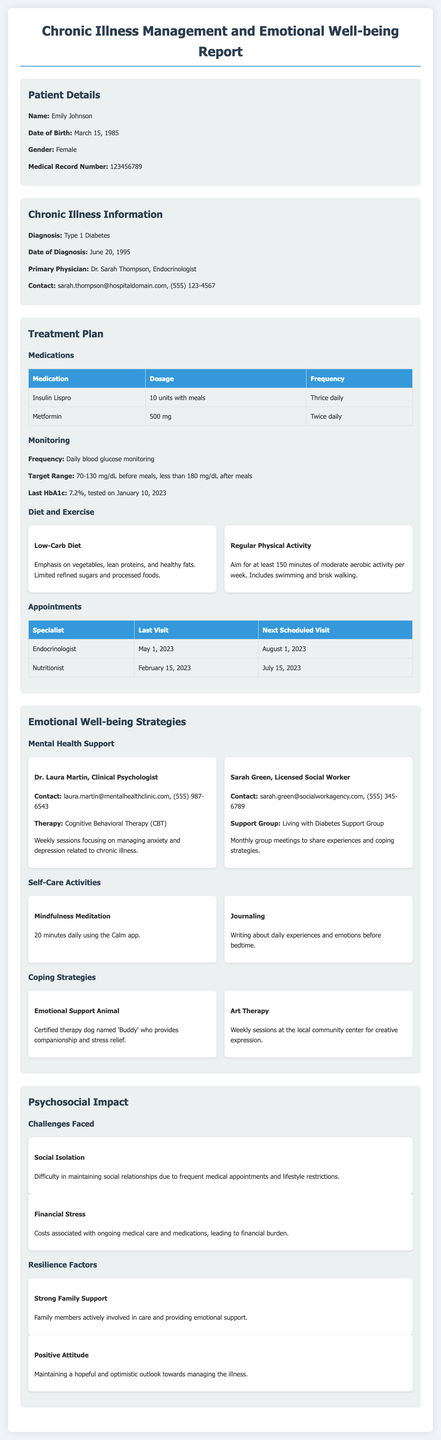what is the patient's name? The patient's name is mentioned in the document under Patient Details.
Answer: Emily Johnson what is the diagnosis? The diagnosis is stated in the Chronic Illness Information section of the report.
Answer: Type 1 Diabetes what medication is prescribed for the patient? The report specifies the medications in the Treatment Plan section.
Answer: Insulin Lispro when was the last visit to the endocrinologist? The date of the last visit is listed in the Appointments subsection of the Treatment Plan.
Answer: May 1, 2023 who provides mental health support? The Mental Health Support subsection identifies the mental health providers mentioned in the report.
Answer: Dr. Laura Martin, Clinical Psychologist how often are sessions with the psychologist scheduled? The frequency of sessions is described in the Mental Health Support subsection.
Answer: Weekly what is one challenge faced by the patient? The report outlines the psychosocial challenges in the Challenges Faced subsection.
Answer: Social Isolation what is the last HbA1c level recorded? The last HbA1c level is documented in the Monitoring subsection of the Treatment Plan.
Answer: 7.2% what type of therapy is offered by the licensed social worker? The type of support offered is mentioned in the Mental Health Support subsection.
Answer: Living with Diabetes Support Group 